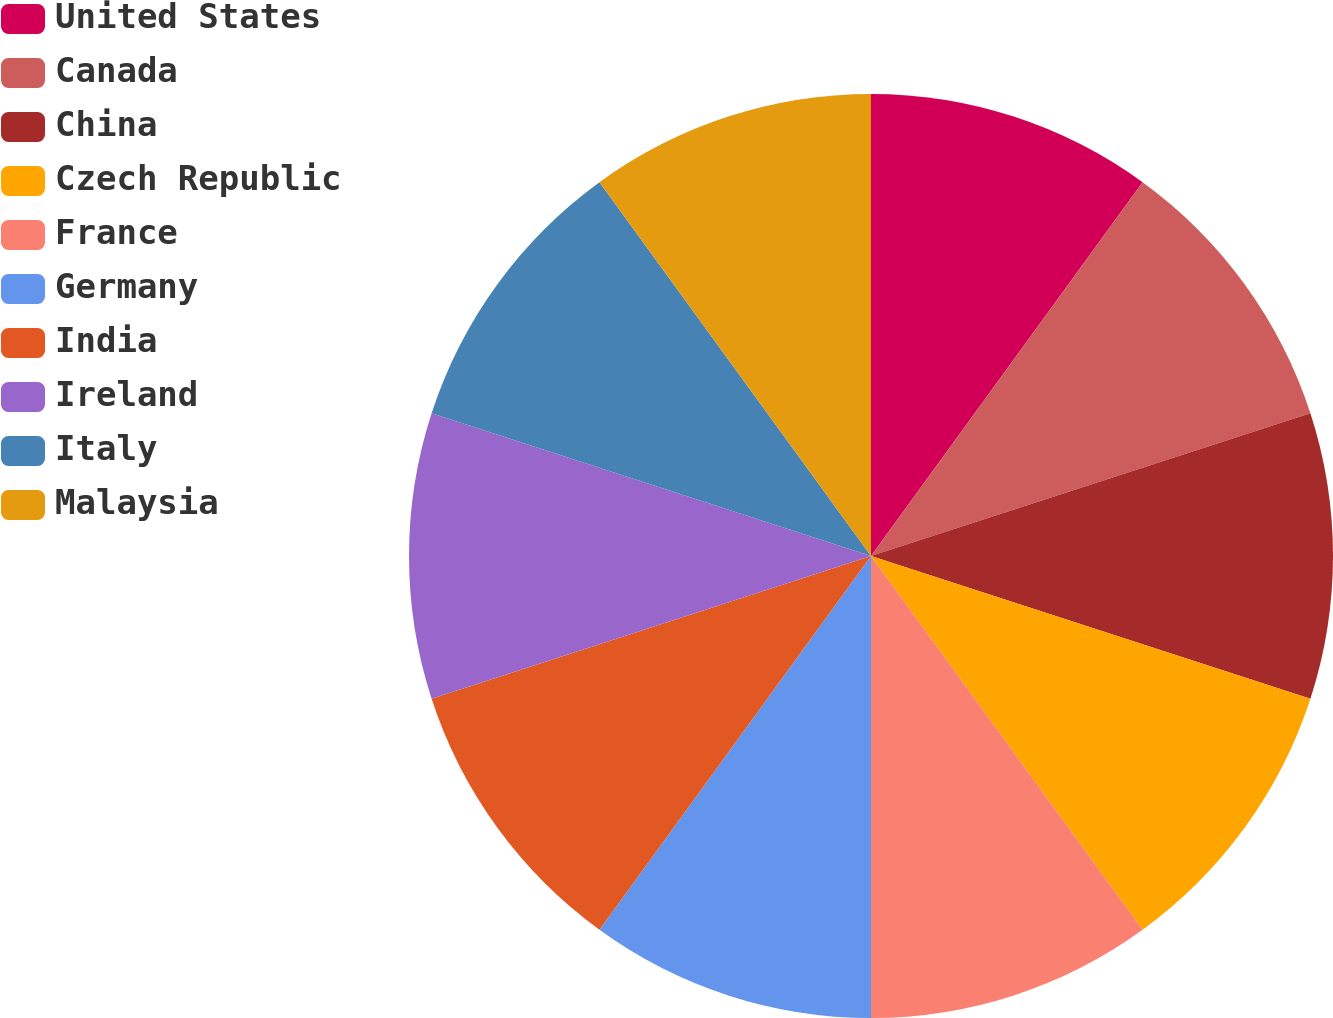Convert chart. <chart><loc_0><loc_0><loc_500><loc_500><pie_chart><fcel>United States<fcel>Canada<fcel>China<fcel>Czech Republic<fcel>France<fcel>Germany<fcel>India<fcel>Ireland<fcel>Italy<fcel>Malaysia<nl><fcel>10.0%<fcel>10.0%<fcel>10.0%<fcel>10.0%<fcel>10.0%<fcel>10.0%<fcel>10.0%<fcel>10.0%<fcel>10.0%<fcel>10.0%<nl></chart> 